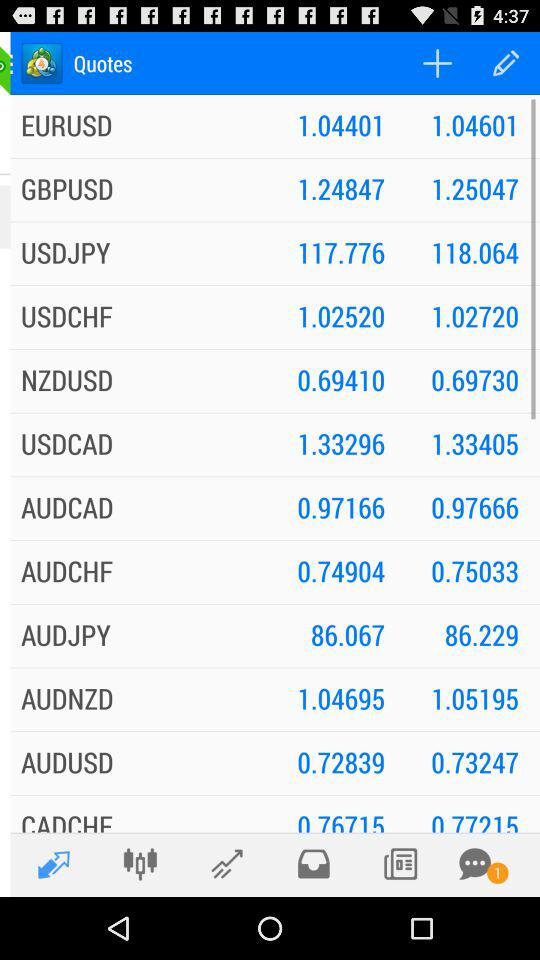How many unread notifications are there? There is 1 unread notification. 